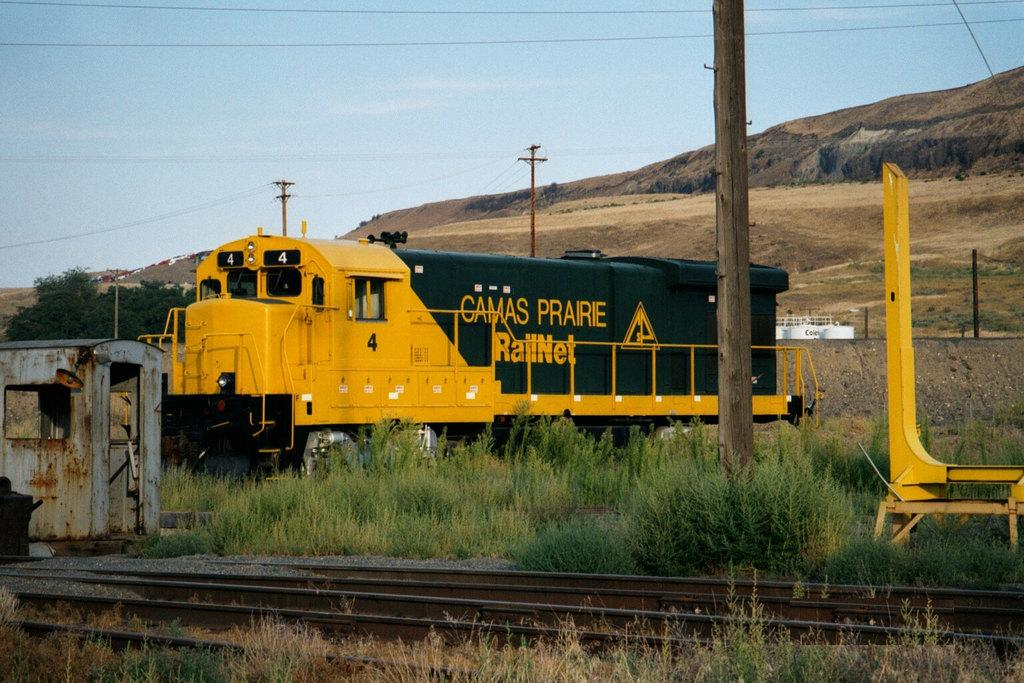<image>
Share a concise interpretation of the image provided. The yellow and green train shown is part of the Camas Prairie Rail network. 